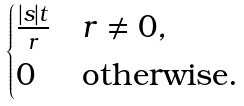Convert formula to latex. <formula><loc_0><loc_0><loc_500><loc_500>\begin{cases} \frac { | s | t } { r } & r \neq { 0 } , \\ 0 & \text {otherwise.} \end{cases}</formula> 